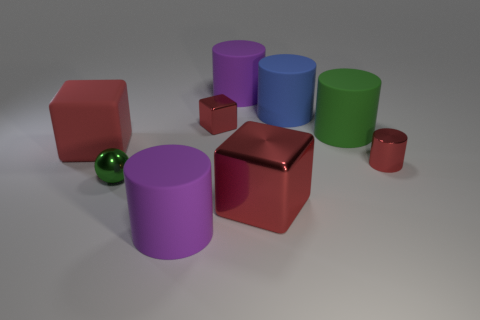Subtract all red blocks. How many were subtracted if there are1red blocks left? 2 Subtract all brown cubes. Subtract all blue cylinders. How many cubes are left? 3 Add 1 big cyan metal cylinders. How many objects exist? 10 Subtract all cubes. How many objects are left? 6 Add 1 big green cylinders. How many big green cylinders exist? 2 Subtract 0 gray spheres. How many objects are left? 9 Subtract all tiny yellow matte cylinders. Subtract all small red metallic things. How many objects are left? 7 Add 7 big blue matte objects. How many big blue matte objects are left? 8 